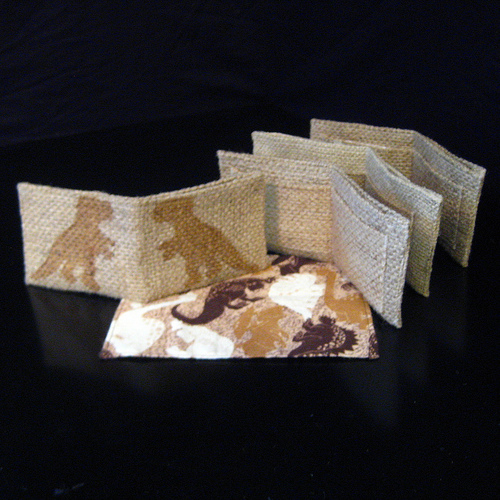<image>
Can you confirm if the wallet is above the place mat? No. The wallet is not positioned above the place mat. The vertical arrangement shows a different relationship. 